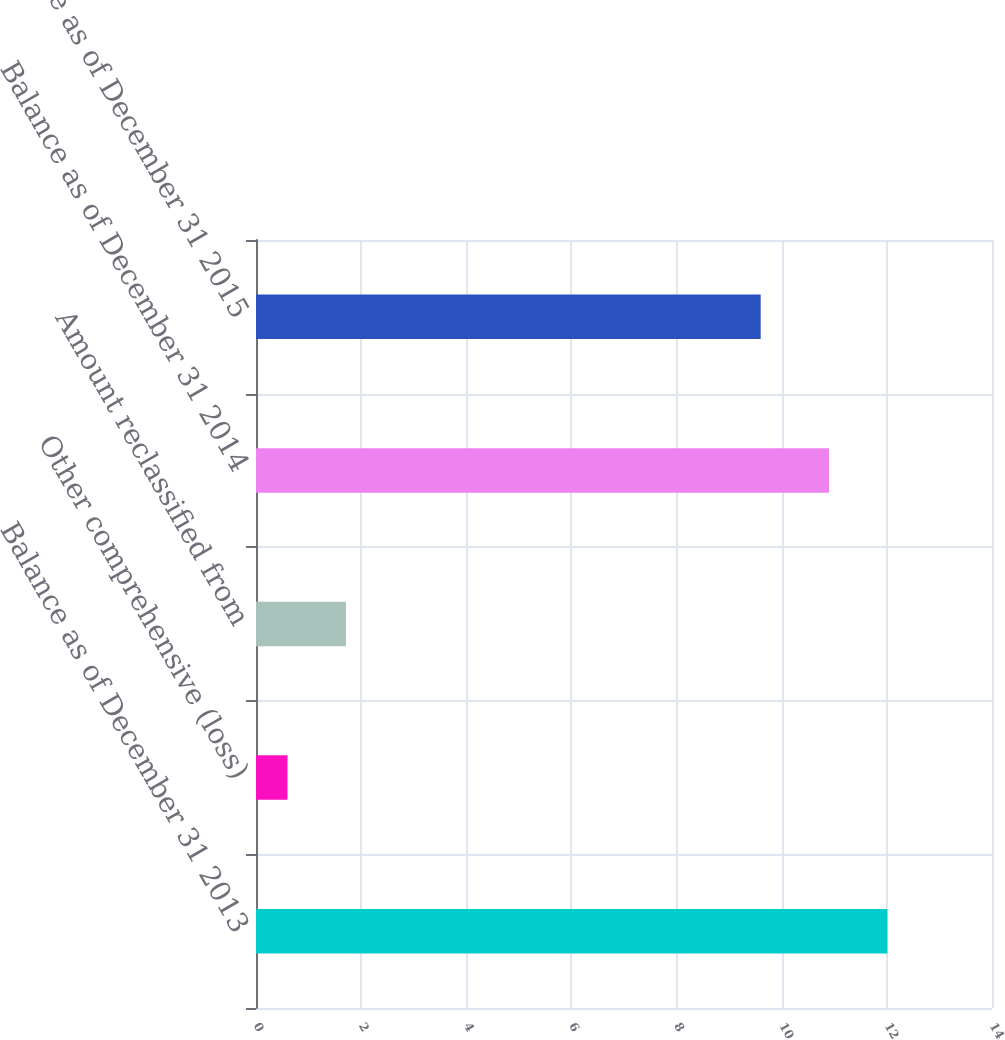<chart> <loc_0><loc_0><loc_500><loc_500><bar_chart><fcel>Balance as of December 31 2013<fcel>Other comprehensive (loss)<fcel>Amount reclassified from<fcel>Balance as of December 31 2014<fcel>Balance as of December 31 2015<nl><fcel>12.01<fcel>0.6<fcel>1.71<fcel>10.9<fcel>9.6<nl></chart> 